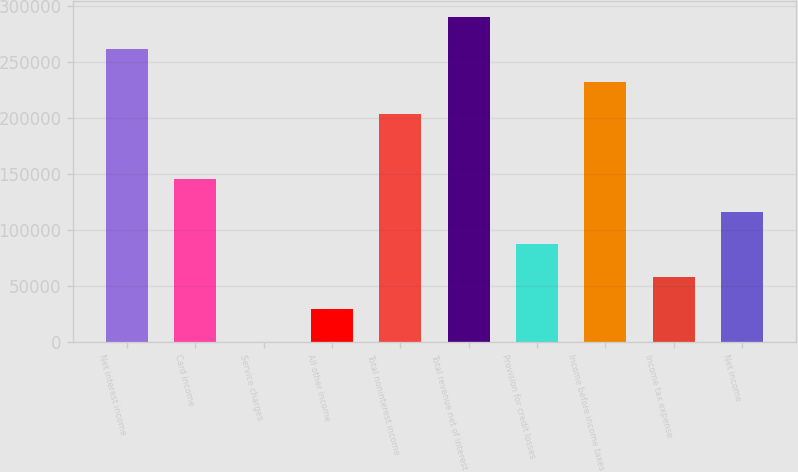<chart> <loc_0><loc_0><loc_500><loc_500><bar_chart><fcel>Net interest income<fcel>Card income<fcel>Service charges<fcel>All other income<fcel>Total noninterest income<fcel>Total revenue net of interest<fcel>Provision for credit losses<fcel>Income before income taxes<fcel>Income tax expense<fcel>Net income<nl><fcel>261061<fcel>145035<fcel>2<fcel>29008.6<fcel>203048<fcel>290068<fcel>87021.8<fcel>232055<fcel>58015.2<fcel>116028<nl></chart> 